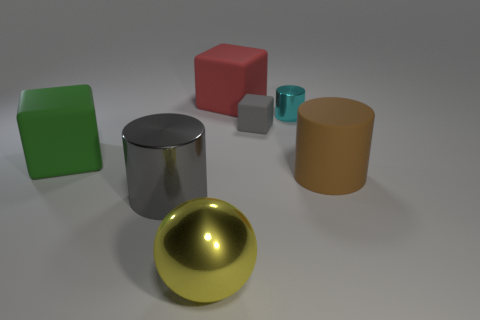Add 3 tiny red metal cylinders. How many objects exist? 10 Subtract all big blocks. How many blocks are left? 1 Subtract 1 cylinders. How many cylinders are left? 2 Subtract all red cubes. How many cubes are left? 2 Subtract all spheres. How many objects are left? 6 Subtract all green cubes. Subtract all green balls. How many cubes are left? 2 Subtract all big gray metal cylinders. Subtract all cubes. How many objects are left? 3 Add 7 red matte blocks. How many red matte blocks are left? 8 Add 4 rubber things. How many rubber things exist? 8 Subtract 0 green cylinders. How many objects are left? 7 